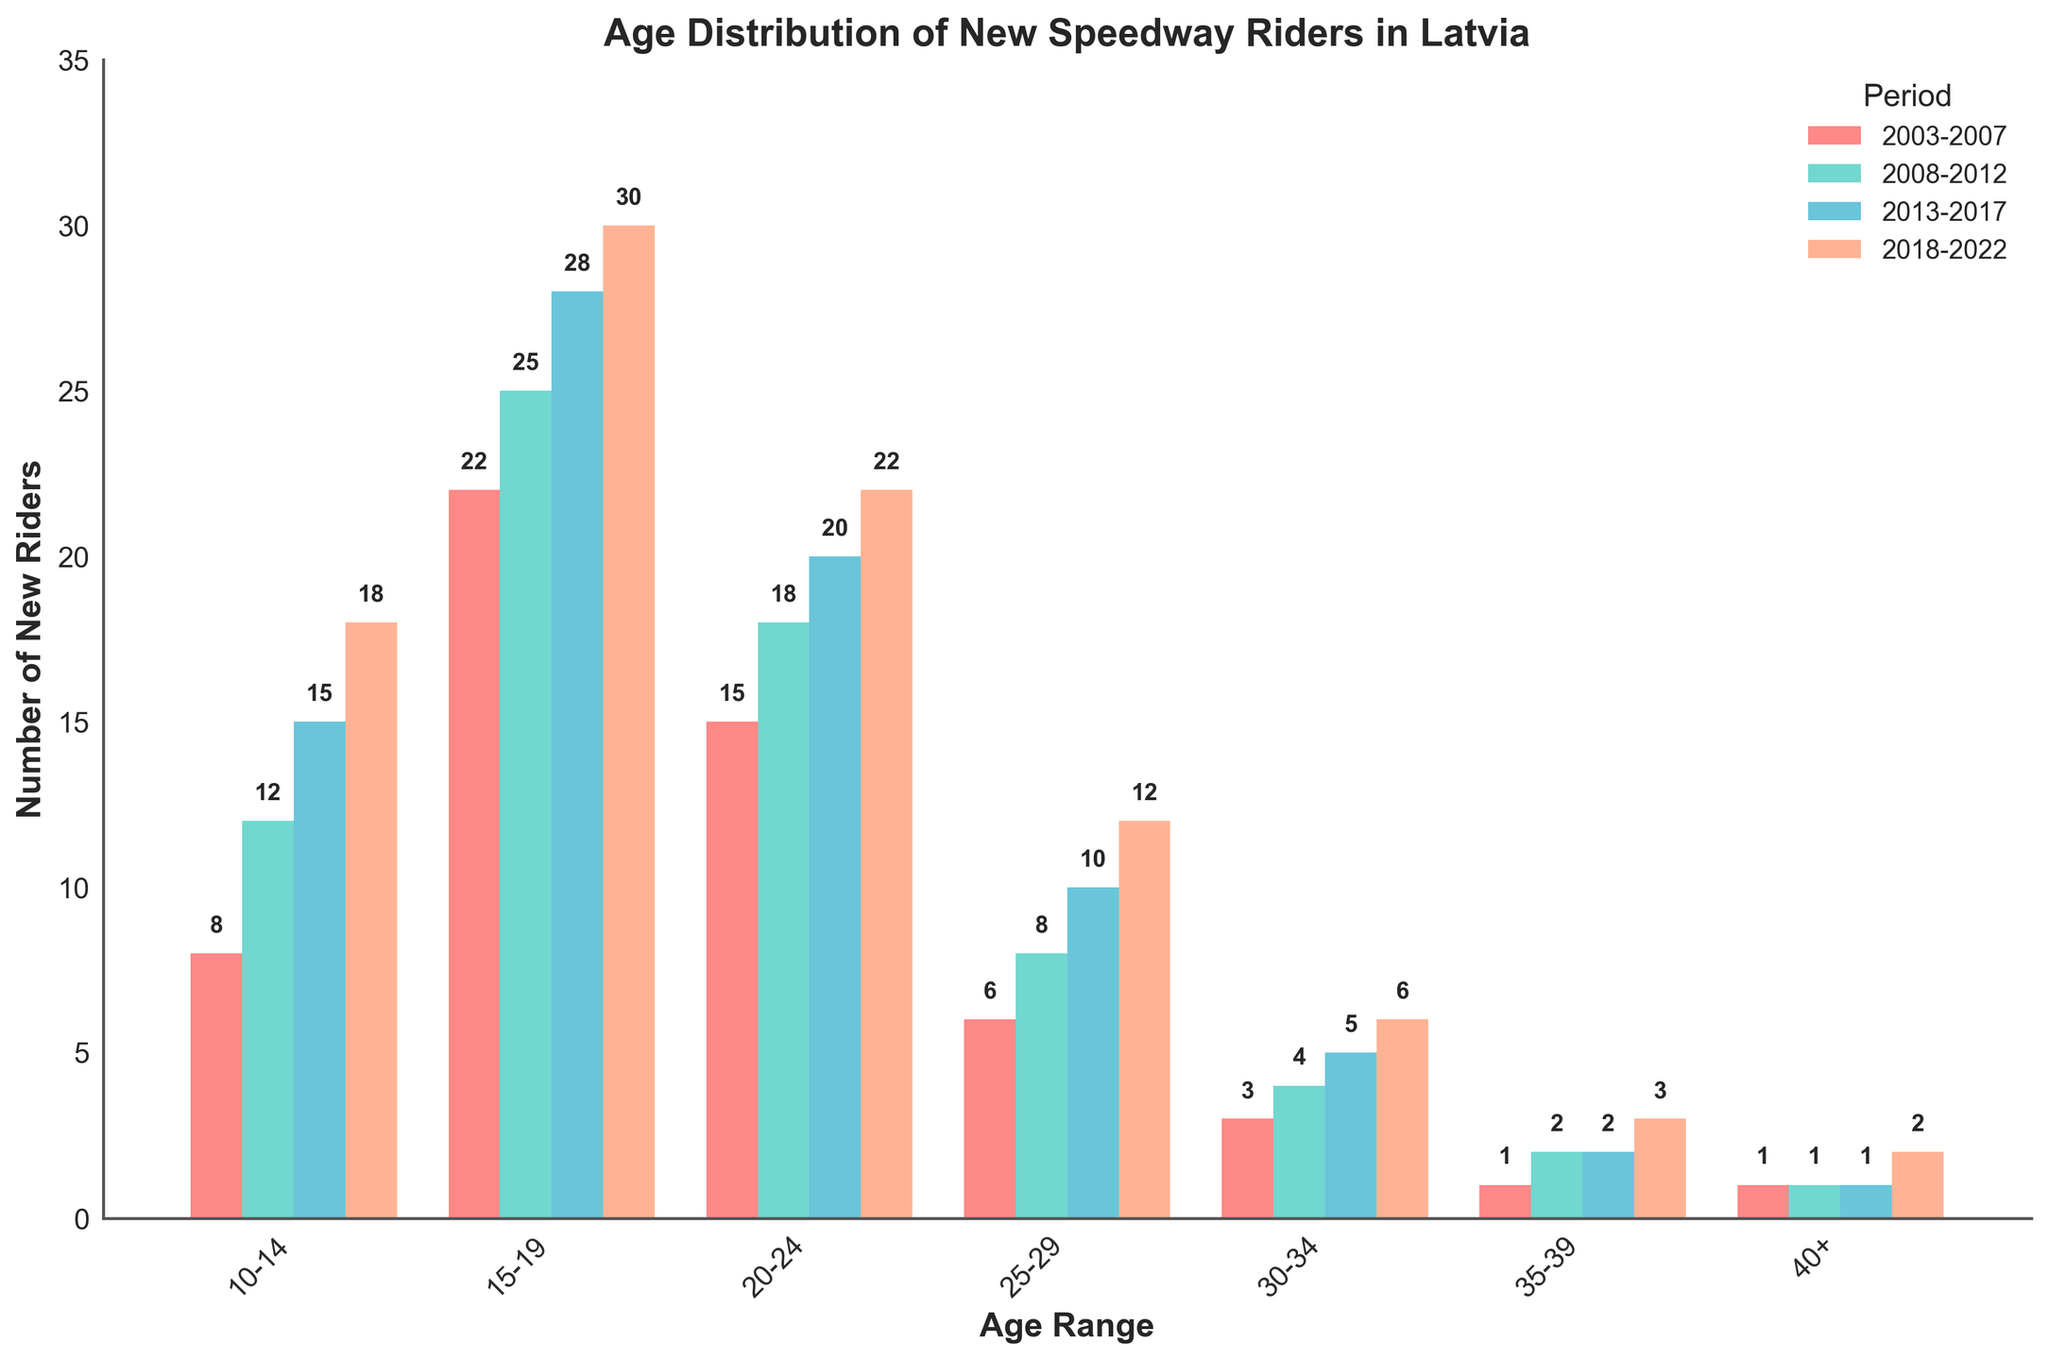Which age range had the highest number of new riders in 2018-2022? The tallest bar in the 2018-2022 group (colored in light orange) belongs to the 15-19 age range with a value of 30.
Answer: 15-19 How has the number of new riders aged 10-14 changed from 2003-2007 to 2018-2022? Compare the heights of the bars representing 10-14 for the periods 2003-2007 (8) and 2018-2022 (18). The number increased by 10.
Answer: Increased by 10 Which period saw the smallest number of new riders aged 35-39? Look at the heights of the bars representing 35-39. The smallest bar is for 2003-2007 with a value of 1.
Answer: 2003-2007 How many more new riders aged 15-19 were there in 2018-2022 compared to 2003-2007? Subtract the number for 2003-2007 (22) from the number for 2018-2022 (30). The difference is 8.
Answer: 8 What is the total number of new riders aged 25-29 across all periods? Add the numbers for 25-29 age range for all periods: 6 (2003-2007) + 8 (2008-2012) + 10 (2013-2017) + 12 (2018-2022). The total is 36.
Answer: 36 Which period had the largest proportion of new riders aged 20-24? Observe the tallest bar in the 20-24 category. The tallest is in 2018-2022 with a value of 22.
Answer: 2018-2022 Is the number of new riders aged 30-34 steadily increasing over the periods? Check if the numbers for 30-34 show a consistent upward trend: 3 (2003-2007), 4 (2008-2012), 5 (2013-2017), 6 (2018-2022). The numbers are steadily increasing.
Answer: Yes How does the number of new riders aged 40+ in 2013-2017 compare to 2018-2022? Compare the bars for 40+ in 2013-2017 (1) and 2018-2022 (2). The number doubled.
Answer: Doubled What is the average number of new riders aged 15-19 over all periods? Add the values for 15-19 for all periods and divide by the number of periods: (22 + 25 + 28 + 30) / 4. The average is 26.25.
Answer: 26.25 Which age range had an increase in new riders in every successive period? Identify the age range where the bars increase for each successive period. 10-14 (8, 12, 15, 18) is the only range with a consistent increase.
Answer: 10-14 